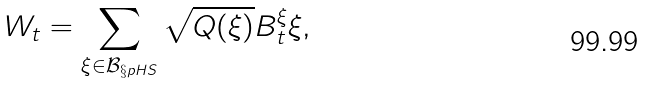<formula> <loc_0><loc_0><loc_500><loc_500>W _ { t } = \sum _ { \xi \in \mathcal { B } _ { \S p H S } } \sqrt { Q ( \xi ) } B _ { t } ^ { \xi } \xi ,</formula> 